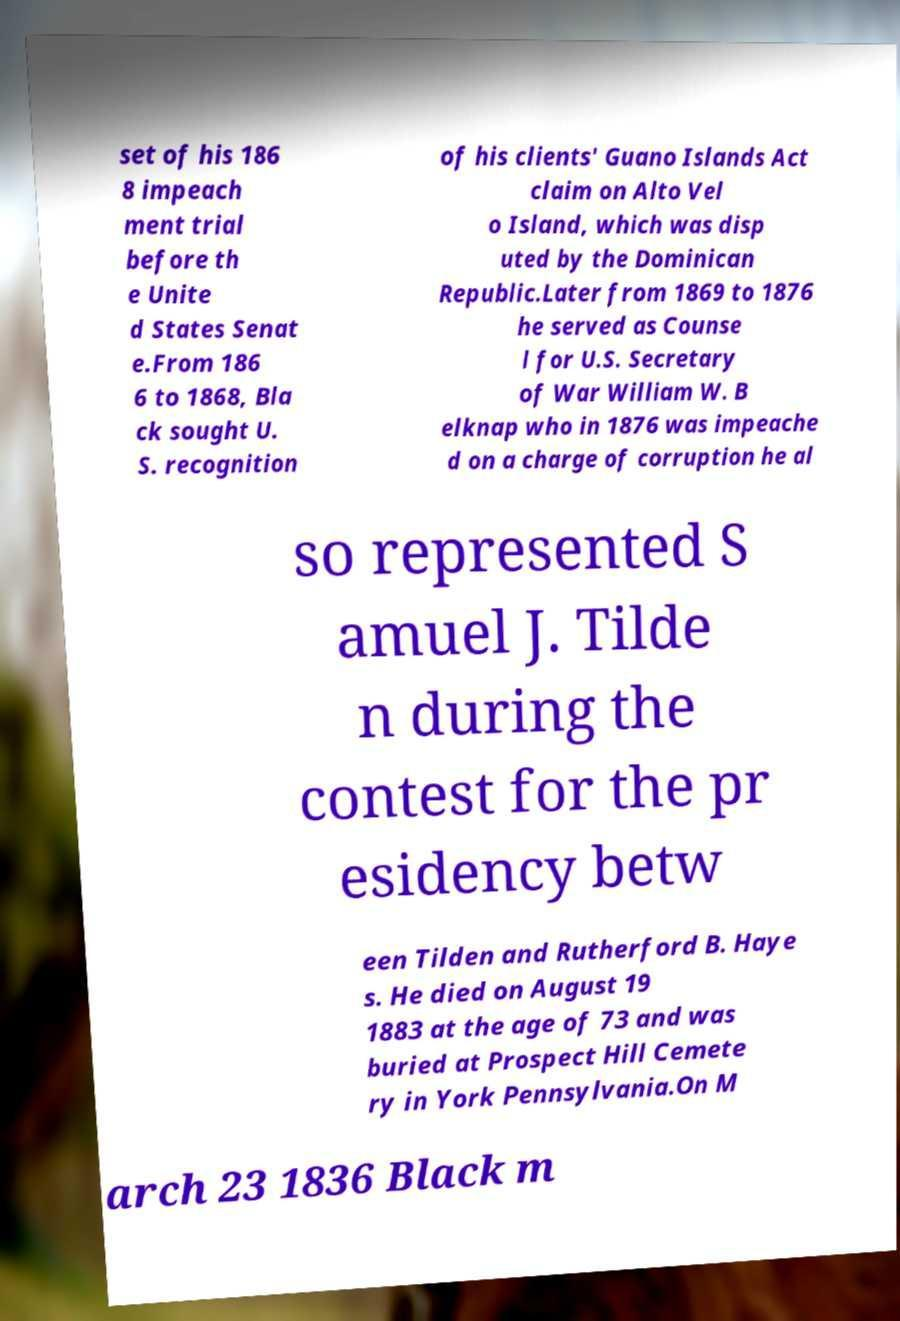Can you read and provide the text displayed in the image?This photo seems to have some interesting text. Can you extract and type it out for me? set of his 186 8 impeach ment trial before th e Unite d States Senat e.From 186 6 to 1868, Bla ck sought U. S. recognition of his clients' Guano Islands Act claim on Alto Vel o Island, which was disp uted by the Dominican Republic.Later from 1869 to 1876 he served as Counse l for U.S. Secretary of War William W. B elknap who in 1876 was impeache d on a charge of corruption he al so represented S amuel J. Tilde n during the contest for the pr esidency betw een Tilden and Rutherford B. Haye s. He died on August 19 1883 at the age of 73 and was buried at Prospect Hill Cemete ry in York Pennsylvania.On M arch 23 1836 Black m 